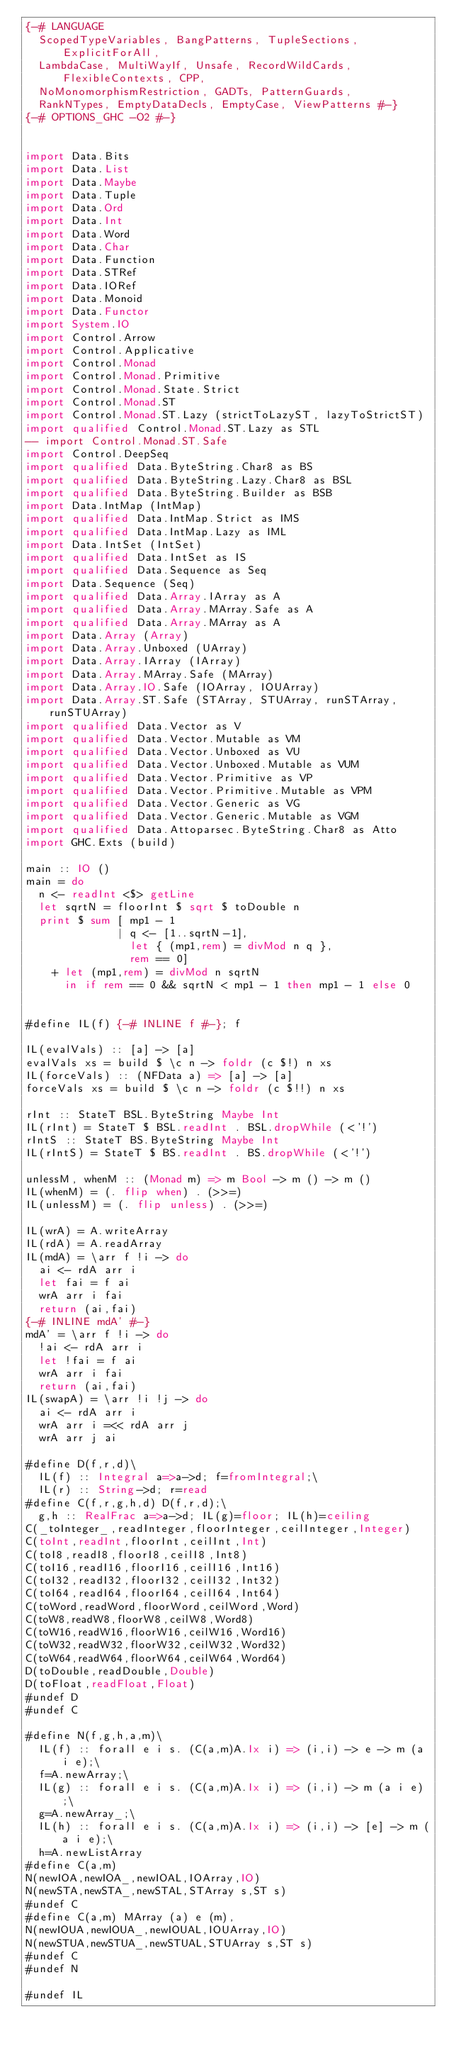Convert code to text. <code><loc_0><loc_0><loc_500><loc_500><_Haskell_>{-# LANGUAGE
  ScopedTypeVariables, BangPatterns, TupleSections, ExplicitForAll,
  LambdaCase, MultiWayIf, Unsafe, RecordWildCards, FlexibleContexts, CPP,
  NoMonomorphismRestriction, GADTs, PatternGuards,
  RankNTypes, EmptyDataDecls, EmptyCase, ViewPatterns #-}
{-# OPTIONS_GHC -O2 #-}


import Data.Bits
import Data.List
import Data.Maybe
import Data.Tuple
import Data.Ord
import Data.Int
import Data.Word
import Data.Char
import Data.Function
import Data.STRef
import Data.IORef
import Data.Monoid
import Data.Functor
import System.IO
import Control.Arrow
import Control.Applicative
import Control.Monad
import Control.Monad.Primitive
import Control.Monad.State.Strict
import Control.Monad.ST
import Control.Monad.ST.Lazy (strictToLazyST, lazyToStrictST)
import qualified Control.Monad.ST.Lazy as STL
-- import Control.Monad.ST.Safe
import Control.DeepSeq
import qualified Data.ByteString.Char8 as BS
import qualified Data.ByteString.Lazy.Char8 as BSL
import qualified Data.ByteString.Builder as BSB
import Data.IntMap (IntMap)
import qualified Data.IntMap.Strict as IMS
import qualified Data.IntMap.Lazy as IML
import Data.IntSet (IntSet)
import qualified Data.IntSet as IS
import qualified Data.Sequence as Seq
import Data.Sequence (Seq)
import qualified Data.Array.IArray as A
import qualified Data.Array.MArray.Safe as A
import qualified Data.Array.MArray as A
import Data.Array (Array)
import Data.Array.Unboxed (UArray)
import Data.Array.IArray (IArray)
import Data.Array.MArray.Safe (MArray)
import Data.Array.IO.Safe (IOArray, IOUArray)
import Data.Array.ST.Safe (STArray, STUArray, runSTArray, runSTUArray)
import qualified Data.Vector as V
import qualified Data.Vector.Mutable as VM
import qualified Data.Vector.Unboxed as VU
import qualified Data.Vector.Unboxed.Mutable as VUM
import qualified Data.Vector.Primitive as VP
import qualified Data.Vector.Primitive.Mutable as VPM
import qualified Data.Vector.Generic as VG
import qualified Data.Vector.Generic.Mutable as VGM
import qualified Data.Attoparsec.ByteString.Char8 as Atto
import GHC.Exts (build)

main :: IO ()
main = do
  n <- readInt <$> getLine
  let sqrtN = floorInt $ sqrt $ toDouble n
  print $ sum [ mp1 - 1
              | q <- [1..sqrtN-1],
                let { (mp1,rem) = divMod n q },
                rem == 0]
    + let (mp1,rem) = divMod n sqrtN
      in if rem == 0 && sqrtN < mp1 - 1 then mp1 - 1 else 0
    

#define IL(f) {-# INLINE f #-}; f

IL(evalVals) :: [a] -> [a]
evalVals xs = build $ \c n -> foldr (c $!) n xs
IL(forceVals) :: (NFData a) => [a] -> [a]
forceVals xs = build $ \c n -> foldr (c $!!) n xs

rInt :: StateT BSL.ByteString Maybe Int
IL(rInt) = StateT $ BSL.readInt . BSL.dropWhile (<'!')
rIntS :: StateT BS.ByteString Maybe Int
IL(rIntS) = StateT $ BS.readInt . BS.dropWhile (<'!')

unlessM, whenM :: (Monad m) => m Bool -> m () -> m ()
IL(whenM) = (. flip when) . (>>=)
IL(unlessM) = (. flip unless) . (>>=)

IL(wrA) = A.writeArray
IL(rdA) = A.readArray
IL(mdA) = \arr f !i -> do
  ai <- rdA arr i
  let fai = f ai 
  wrA arr i fai
  return (ai,fai)
{-# INLINE mdA' #-}
mdA' = \arr f !i -> do
  !ai <- rdA arr i
  let !fai = f ai
  wrA arr i fai
  return (ai,fai)
IL(swapA) = \arr !i !j -> do
  ai <- rdA arr i
  wrA arr i =<< rdA arr j
  wrA arr j ai

#define D(f,r,d)\
  IL(f) :: Integral a=>a->d; f=fromIntegral;\
  IL(r) :: String->d; r=read
#define C(f,r,g,h,d) D(f,r,d);\
  g,h :: RealFrac a=>a->d; IL(g)=floor; IL(h)=ceiling
C(_toInteger_,readInteger,floorInteger,ceilInteger,Integer)
C(toInt,readInt,floorInt,ceilInt,Int)
C(toI8,readI8,floorI8,ceilI8,Int8)
C(toI16,readI16,floorI16,ceilI16,Int16)
C(toI32,readI32,floorI32,ceilI32,Int32)
C(toI64,readI64,floorI64,ceilI64,Int64)
C(toWord,readWord,floorWord,ceilWord,Word)
C(toW8,readW8,floorW8,ceilW8,Word8)
C(toW16,readW16,floorW16,ceilW16,Word16)
C(toW32,readW32,floorW32,ceilW32,Word32)
C(toW64,readW64,floorW64,ceilW64,Word64)
D(toDouble,readDouble,Double)
D(toFloat,readFloat,Float)
#undef D
#undef C

#define N(f,g,h,a,m)\
  IL(f) :: forall e i s. (C(a,m)A.Ix i) => (i,i) -> e -> m (a i e);\
  f=A.newArray;\
  IL(g) :: forall e i s. (C(a,m)A.Ix i) => (i,i) -> m (a i e);\
  g=A.newArray_;\
  IL(h) :: forall e i s. (C(a,m)A.Ix i) => (i,i) -> [e] -> m (a i e);\
  h=A.newListArray
#define C(a,m)
N(newIOA,newIOA_,newIOAL,IOArray,IO)
N(newSTA,newSTA_,newSTAL,STArray s,ST s)
#undef C
#define C(a,m) MArray (a) e (m), 
N(newIOUA,newIOUA_,newIOUAL,IOUArray,IO)
N(newSTUA,newSTUA_,newSTUAL,STUArray s,ST s)
#undef C
#undef N

#undef IL
</code> 